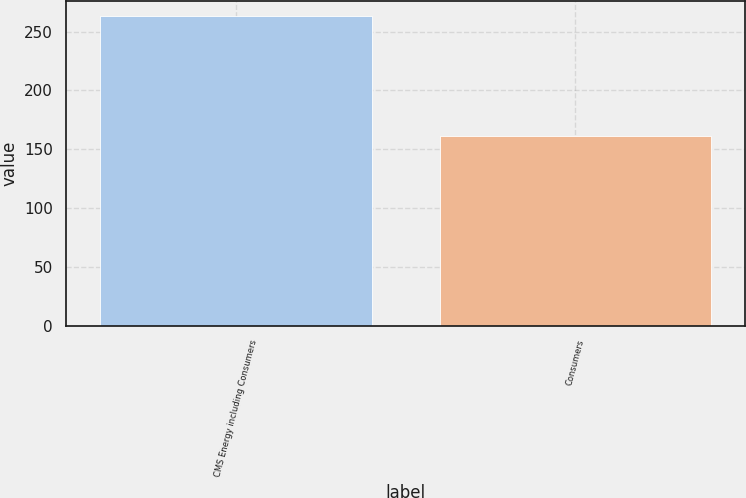Convert chart. <chart><loc_0><loc_0><loc_500><loc_500><bar_chart><fcel>CMS Energy including Consumers<fcel>Consumers<nl><fcel>263<fcel>161<nl></chart> 